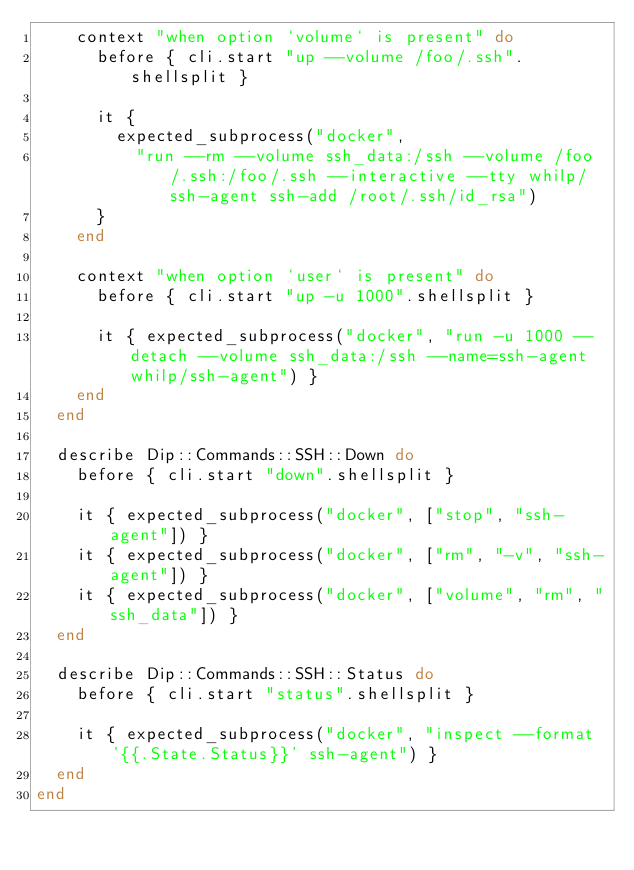<code> <loc_0><loc_0><loc_500><loc_500><_Ruby_>    context "when option `volume` is present" do
      before { cli.start "up --volume /foo/.ssh".shellsplit }

      it {
        expected_subprocess("docker",
          "run --rm --volume ssh_data:/ssh --volume /foo/.ssh:/foo/.ssh --interactive --tty whilp/ssh-agent ssh-add /root/.ssh/id_rsa")
      }
    end

    context "when option `user` is present" do
      before { cli.start "up -u 1000".shellsplit }

      it { expected_subprocess("docker", "run -u 1000 --detach --volume ssh_data:/ssh --name=ssh-agent whilp/ssh-agent") }
    end
  end

  describe Dip::Commands::SSH::Down do
    before { cli.start "down".shellsplit }

    it { expected_subprocess("docker", ["stop", "ssh-agent"]) }
    it { expected_subprocess("docker", ["rm", "-v", "ssh-agent"]) }
    it { expected_subprocess("docker", ["volume", "rm", "ssh_data"]) }
  end

  describe Dip::Commands::SSH::Status do
    before { cli.start "status".shellsplit }

    it { expected_subprocess("docker", "inspect --format '{{.State.Status}}' ssh-agent") }
  end
end
</code> 